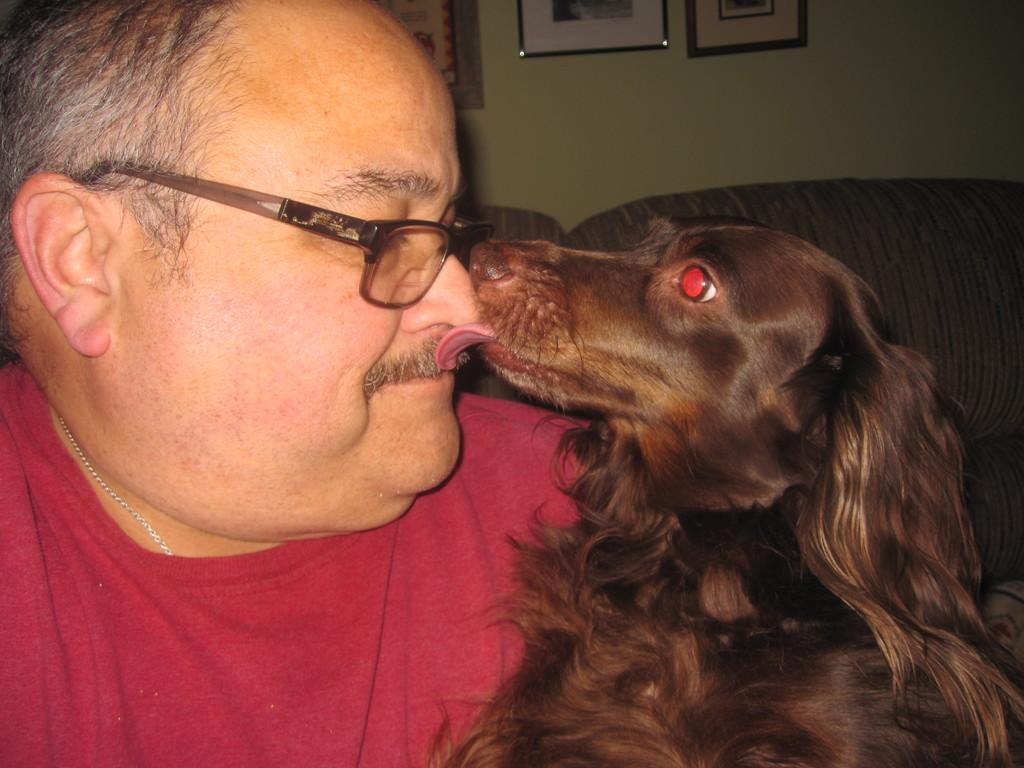What animal is present in the image? There is a dog in the image. What is the dog doing in the image? The dog is licking a man's nose. What type of locket is the dog wearing around its neck in the image? There is no locket present in the image; the dog is not wearing any accessories. 